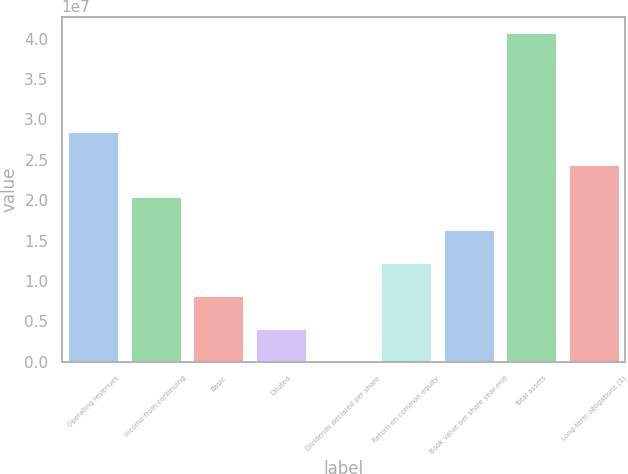Convert chart. <chart><loc_0><loc_0><loc_500><loc_500><bar_chart><fcel>Operating revenues<fcel>Income from continuing<fcel>Basic<fcel>Diluted<fcel>Dividends declared per share<fcel>Return on common equity<fcel>Book value per share year-end<fcel>Total assets<fcel>Long-term obligations (1)<nl><fcel>2.84912e+07<fcel>2.03509e+07<fcel>8.14034e+06<fcel>4.07017e+06<fcel>3.32<fcel>1.22105e+07<fcel>1.62807e+07<fcel>4.07017e+07<fcel>2.4421e+07<nl></chart> 